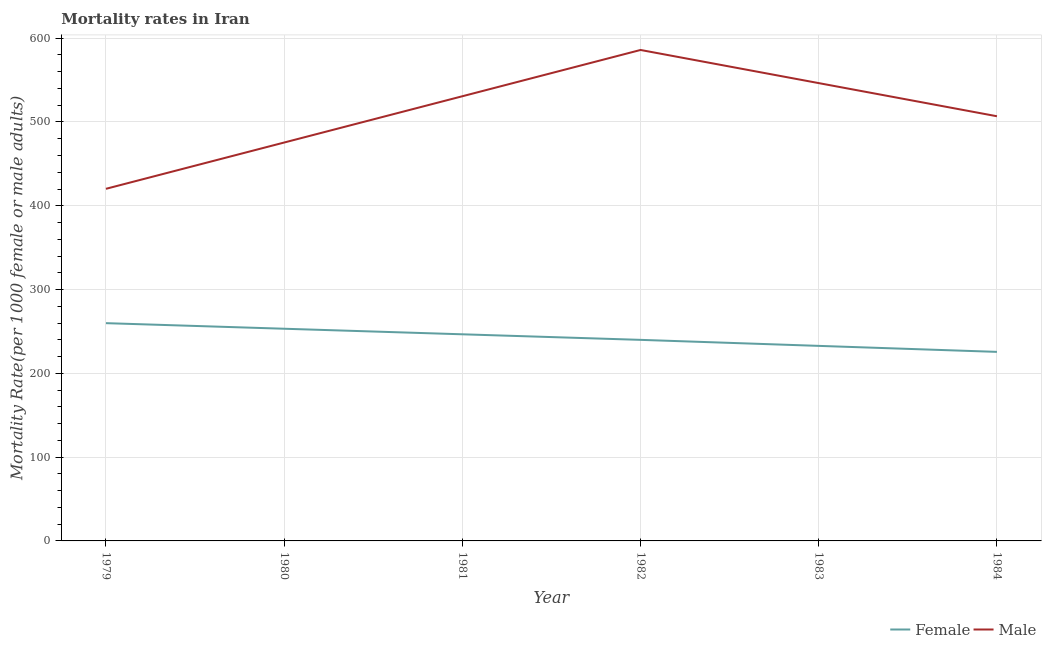How many different coloured lines are there?
Your response must be concise. 2. What is the female mortality rate in 1979?
Provide a succinct answer. 259.89. Across all years, what is the maximum female mortality rate?
Your answer should be very brief. 259.89. Across all years, what is the minimum female mortality rate?
Your response must be concise. 225.63. In which year was the female mortality rate minimum?
Ensure brevity in your answer.  1984. What is the total male mortality rate in the graph?
Ensure brevity in your answer.  3065.62. What is the difference between the male mortality rate in 1979 and that in 1983?
Keep it short and to the point. -126.16. What is the difference between the male mortality rate in 1979 and the female mortality rate in 1980?
Offer a very short reply. 166.99. What is the average male mortality rate per year?
Give a very brief answer. 510.94. In the year 1979, what is the difference between the male mortality rate and female mortality rate?
Your answer should be very brief. 160.35. What is the ratio of the male mortality rate in 1981 to that in 1982?
Your answer should be compact. 0.91. Is the male mortality rate in 1980 less than that in 1981?
Provide a short and direct response. Yes. Is the difference between the female mortality rate in 1981 and 1982 greater than the difference between the male mortality rate in 1981 and 1982?
Provide a succinct answer. Yes. What is the difference between the highest and the second highest female mortality rate?
Provide a short and direct response. 6.64. What is the difference between the highest and the lowest male mortality rate?
Ensure brevity in your answer.  165.71. Is the female mortality rate strictly less than the male mortality rate over the years?
Provide a succinct answer. Yes. How many lines are there?
Your answer should be compact. 2. What is the difference between two consecutive major ticks on the Y-axis?
Provide a succinct answer. 100. Are the values on the major ticks of Y-axis written in scientific E-notation?
Your answer should be compact. No. Does the graph contain grids?
Ensure brevity in your answer.  Yes. How many legend labels are there?
Offer a very short reply. 2. What is the title of the graph?
Ensure brevity in your answer.  Mortality rates in Iran. What is the label or title of the Y-axis?
Keep it short and to the point. Mortality Rate(per 1000 female or male adults). What is the Mortality Rate(per 1000 female or male adults) in Female in 1979?
Offer a terse response. 259.89. What is the Mortality Rate(per 1000 female or male adults) of Male in 1979?
Offer a very short reply. 420.24. What is the Mortality Rate(per 1000 female or male adults) of Female in 1980?
Keep it short and to the point. 253.25. What is the Mortality Rate(per 1000 female or male adults) in Male in 1980?
Ensure brevity in your answer.  475.48. What is the Mortality Rate(per 1000 female or male adults) in Female in 1981?
Ensure brevity in your answer.  246.61. What is the Mortality Rate(per 1000 female or male adults) of Male in 1981?
Your answer should be very brief. 530.71. What is the Mortality Rate(per 1000 female or male adults) of Female in 1982?
Give a very brief answer. 239.96. What is the Mortality Rate(per 1000 female or male adults) in Male in 1982?
Provide a succinct answer. 585.95. What is the Mortality Rate(per 1000 female or male adults) of Female in 1983?
Your answer should be very brief. 232.79. What is the Mortality Rate(per 1000 female or male adults) in Male in 1983?
Give a very brief answer. 546.4. What is the Mortality Rate(per 1000 female or male adults) of Female in 1984?
Provide a succinct answer. 225.63. What is the Mortality Rate(per 1000 female or male adults) of Male in 1984?
Make the answer very short. 506.84. Across all years, what is the maximum Mortality Rate(per 1000 female or male adults) of Female?
Your answer should be very brief. 259.89. Across all years, what is the maximum Mortality Rate(per 1000 female or male adults) of Male?
Ensure brevity in your answer.  585.95. Across all years, what is the minimum Mortality Rate(per 1000 female or male adults) in Female?
Provide a succinct answer. 225.63. Across all years, what is the minimum Mortality Rate(per 1000 female or male adults) in Male?
Your answer should be compact. 420.24. What is the total Mortality Rate(per 1000 female or male adults) in Female in the graph?
Offer a terse response. 1458.13. What is the total Mortality Rate(per 1000 female or male adults) of Male in the graph?
Keep it short and to the point. 3065.62. What is the difference between the Mortality Rate(per 1000 female or male adults) of Female in 1979 and that in 1980?
Offer a very short reply. 6.64. What is the difference between the Mortality Rate(per 1000 female or male adults) of Male in 1979 and that in 1980?
Ensure brevity in your answer.  -55.24. What is the difference between the Mortality Rate(per 1000 female or male adults) of Female in 1979 and that in 1981?
Offer a terse response. 13.29. What is the difference between the Mortality Rate(per 1000 female or male adults) of Male in 1979 and that in 1981?
Offer a very short reply. -110.47. What is the difference between the Mortality Rate(per 1000 female or male adults) of Female in 1979 and that in 1982?
Your answer should be compact. 19.93. What is the difference between the Mortality Rate(per 1000 female or male adults) of Male in 1979 and that in 1982?
Provide a short and direct response. -165.71. What is the difference between the Mortality Rate(per 1000 female or male adults) in Female in 1979 and that in 1983?
Ensure brevity in your answer.  27.1. What is the difference between the Mortality Rate(per 1000 female or male adults) in Male in 1979 and that in 1983?
Provide a succinct answer. -126.16. What is the difference between the Mortality Rate(per 1000 female or male adults) of Female in 1979 and that in 1984?
Ensure brevity in your answer.  34.27. What is the difference between the Mortality Rate(per 1000 female or male adults) in Male in 1979 and that in 1984?
Keep it short and to the point. -86.6. What is the difference between the Mortality Rate(per 1000 female or male adults) in Female in 1980 and that in 1981?
Make the answer very short. 6.64. What is the difference between the Mortality Rate(per 1000 female or male adults) in Male in 1980 and that in 1981?
Give a very brief answer. -55.24. What is the difference between the Mortality Rate(per 1000 female or male adults) of Female in 1980 and that in 1982?
Provide a short and direct response. 13.29. What is the difference between the Mortality Rate(per 1000 female or male adults) of Male in 1980 and that in 1982?
Your answer should be very brief. -110.47. What is the difference between the Mortality Rate(per 1000 female or male adults) of Female in 1980 and that in 1983?
Provide a succinct answer. 20.46. What is the difference between the Mortality Rate(per 1000 female or male adults) of Male in 1980 and that in 1983?
Keep it short and to the point. -70.92. What is the difference between the Mortality Rate(per 1000 female or male adults) in Female in 1980 and that in 1984?
Keep it short and to the point. 27.62. What is the difference between the Mortality Rate(per 1000 female or male adults) in Male in 1980 and that in 1984?
Keep it short and to the point. -31.36. What is the difference between the Mortality Rate(per 1000 female or male adults) of Female in 1981 and that in 1982?
Your answer should be compact. 6.64. What is the difference between the Mortality Rate(per 1000 female or male adults) in Male in 1981 and that in 1982?
Provide a succinct answer. -55.24. What is the difference between the Mortality Rate(per 1000 female or male adults) of Female in 1981 and that in 1983?
Your answer should be compact. 13.81. What is the difference between the Mortality Rate(per 1000 female or male adults) of Male in 1981 and that in 1983?
Provide a succinct answer. -15.68. What is the difference between the Mortality Rate(per 1000 female or male adults) of Female in 1981 and that in 1984?
Ensure brevity in your answer.  20.98. What is the difference between the Mortality Rate(per 1000 female or male adults) of Male in 1981 and that in 1984?
Offer a very short reply. 23.87. What is the difference between the Mortality Rate(per 1000 female or male adults) in Female in 1982 and that in 1983?
Your answer should be very brief. 7.17. What is the difference between the Mortality Rate(per 1000 female or male adults) in Male in 1982 and that in 1983?
Keep it short and to the point. 39.55. What is the difference between the Mortality Rate(per 1000 female or male adults) in Female in 1982 and that in 1984?
Make the answer very short. 14.33. What is the difference between the Mortality Rate(per 1000 female or male adults) in Male in 1982 and that in 1984?
Make the answer very short. 79.11. What is the difference between the Mortality Rate(per 1000 female or male adults) in Female in 1983 and that in 1984?
Ensure brevity in your answer.  7.17. What is the difference between the Mortality Rate(per 1000 female or male adults) in Male in 1983 and that in 1984?
Your answer should be very brief. 39.55. What is the difference between the Mortality Rate(per 1000 female or male adults) in Female in 1979 and the Mortality Rate(per 1000 female or male adults) in Male in 1980?
Give a very brief answer. -215.58. What is the difference between the Mortality Rate(per 1000 female or male adults) of Female in 1979 and the Mortality Rate(per 1000 female or male adults) of Male in 1981?
Your response must be concise. -270.82. What is the difference between the Mortality Rate(per 1000 female or male adults) in Female in 1979 and the Mortality Rate(per 1000 female or male adults) in Male in 1982?
Provide a succinct answer. -326.06. What is the difference between the Mortality Rate(per 1000 female or male adults) of Female in 1979 and the Mortality Rate(per 1000 female or male adults) of Male in 1983?
Offer a terse response. -286.5. What is the difference between the Mortality Rate(per 1000 female or male adults) in Female in 1979 and the Mortality Rate(per 1000 female or male adults) in Male in 1984?
Provide a short and direct response. -246.95. What is the difference between the Mortality Rate(per 1000 female or male adults) of Female in 1980 and the Mortality Rate(per 1000 female or male adults) of Male in 1981?
Keep it short and to the point. -277.46. What is the difference between the Mortality Rate(per 1000 female or male adults) in Female in 1980 and the Mortality Rate(per 1000 female or male adults) in Male in 1982?
Offer a very short reply. -332.7. What is the difference between the Mortality Rate(per 1000 female or male adults) of Female in 1980 and the Mortality Rate(per 1000 female or male adults) of Male in 1983?
Provide a succinct answer. -293.15. What is the difference between the Mortality Rate(per 1000 female or male adults) in Female in 1980 and the Mortality Rate(per 1000 female or male adults) in Male in 1984?
Ensure brevity in your answer.  -253.59. What is the difference between the Mortality Rate(per 1000 female or male adults) in Female in 1981 and the Mortality Rate(per 1000 female or male adults) in Male in 1982?
Make the answer very short. -339.35. What is the difference between the Mortality Rate(per 1000 female or male adults) in Female in 1981 and the Mortality Rate(per 1000 female or male adults) in Male in 1983?
Your answer should be very brief. -299.79. What is the difference between the Mortality Rate(per 1000 female or male adults) in Female in 1981 and the Mortality Rate(per 1000 female or male adults) in Male in 1984?
Your response must be concise. -260.24. What is the difference between the Mortality Rate(per 1000 female or male adults) of Female in 1982 and the Mortality Rate(per 1000 female or male adults) of Male in 1983?
Give a very brief answer. -306.44. What is the difference between the Mortality Rate(per 1000 female or male adults) of Female in 1982 and the Mortality Rate(per 1000 female or male adults) of Male in 1984?
Keep it short and to the point. -266.88. What is the difference between the Mortality Rate(per 1000 female or male adults) in Female in 1983 and the Mortality Rate(per 1000 female or male adults) in Male in 1984?
Keep it short and to the point. -274.05. What is the average Mortality Rate(per 1000 female or male adults) in Female per year?
Provide a short and direct response. 243.02. What is the average Mortality Rate(per 1000 female or male adults) in Male per year?
Your response must be concise. 510.94. In the year 1979, what is the difference between the Mortality Rate(per 1000 female or male adults) of Female and Mortality Rate(per 1000 female or male adults) of Male?
Provide a succinct answer. -160.35. In the year 1980, what is the difference between the Mortality Rate(per 1000 female or male adults) of Female and Mortality Rate(per 1000 female or male adults) of Male?
Provide a succinct answer. -222.23. In the year 1981, what is the difference between the Mortality Rate(per 1000 female or male adults) in Female and Mortality Rate(per 1000 female or male adults) in Male?
Keep it short and to the point. -284.11. In the year 1982, what is the difference between the Mortality Rate(per 1000 female or male adults) of Female and Mortality Rate(per 1000 female or male adults) of Male?
Your answer should be very brief. -345.99. In the year 1983, what is the difference between the Mortality Rate(per 1000 female or male adults) of Female and Mortality Rate(per 1000 female or male adults) of Male?
Your answer should be compact. -313.6. In the year 1984, what is the difference between the Mortality Rate(per 1000 female or male adults) of Female and Mortality Rate(per 1000 female or male adults) of Male?
Your answer should be very brief. -281.22. What is the ratio of the Mortality Rate(per 1000 female or male adults) of Female in 1979 to that in 1980?
Make the answer very short. 1.03. What is the ratio of the Mortality Rate(per 1000 female or male adults) in Male in 1979 to that in 1980?
Give a very brief answer. 0.88. What is the ratio of the Mortality Rate(per 1000 female or male adults) in Female in 1979 to that in 1981?
Make the answer very short. 1.05. What is the ratio of the Mortality Rate(per 1000 female or male adults) in Male in 1979 to that in 1981?
Ensure brevity in your answer.  0.79. What is the ratio of the Mortality Rate(per 1000 female or male adults) in Female in 1979 to that in 1982?
Offer a very short reply. 1.08. What is the ratio of the Mortality Rate(per 1000 female or male adults) of Male in 1979 to that in 1982?
Offer a very short reply. 0.72. What is the ratio of the Mortality Rate(per 1000 female or male adults) of Female in 1979 to that in 1983?
Provide a short and direct response. 1.12. What is the ratio of the Mortality Rate(per 1000 female or male adults) in Male in 1979 to that in 1983?
Your response must be concise. 0.77. What is the ratio of the Mortality Rate(per 1000 female or male adults) of Female in 1979 to that in 1984?
Provide a succinct answer. 1.15. What is the ratio of the Mortality Rate(per 1000 female or male adults) of Male in 1979 to that in 1984?
Your answer should be compact. 0.83. What is the ratio of the Mortality Rate(per 1000 female or male adults) in Female in 1980 to that in 1981?
Provide a short and direct response. 1.03. What is the ratio of the Mortality Rate(per 1000 female or male adults) in Male in 1980 to that in 1981?
Your answer should be compact. 0.9. What is the ratio of the Mortality Rate(per 1000 female or male adults) of Female in 1980 to that in 1982?
Offer a very short reply. 1.06. What is the ratio of the Mortality Rate(per 1000 female or male adults) in Male in 1980 to that in 1982?
Keep it short and to the point. 0.81. What is the ratio of the Mortality Rate(per 1000 female or male adults) in Female in 1980 to that in 1983?
Provide a succinct answer. 1.09. What is the ratio of the Mortality Rate(per 1000 female or male adults) in Male in 1980 to that in 1983?
Your answer should be very brief. 0.87. What is the ratio of the Mortality Rate(per 1000 female or male adults) of Female in 1980 to that in 1984?
Your answer should be very brief. 1.12. What is the ratio of the Mortality Rate(per 1000 female or male adults) in Male in 1980 to that in 1984?
Ensure brevity in your answer.  0.94. What is the ratio of the Mortality Rate(per 1000 female or male adults) of Female in 1981 to that in 1982?
Your answer should be compact. 1.03. What is the ratio of the Mortality Rate(per 1000 female or male adults) of Male in 1981 to that in 1982?
Ensure brevity in your answer.  0.91. What is the ratio of the Mortality Rate(per 1000 female or male adults) of Female in 1981 to that in 1983?
Offer a very short reply. 1.06. What is the ratio of the Mortality Rate(per 1000 female or male adults) of Male in 1981 to that in 1983?
Your answer should be very brief. 0.97. What is the ratio of the Mortality Rate(per 1000 female or male adults) in Female in 1981 to that in 1984?
Your answer should be compact. 1.09. What is the ratio of the Mortality Rate(per 1000 female or male adults) in Male in 1981 to that in 1984?
Your answer should be compact. 1.05. What is the ratio of the Mortality Rate(per 1000 female or male adults) of Female in 1982 to that in 1983?
Provide a succinct answer. 1.03. What is the ratio of the Mortality Rate(per 1000 female or male adults) of Male in 1982 to that in 1983?
Provide a short and direct response. 1.07. What is the ratio of the Mortality Rate(per 1000 female or male adults) of Female in 1982 to that in 1984?
Provide a succinct answer. 1.06. What is the ratio of the Mortality Rate(per 1000 female or male adults) in Male in 1982 to that in 1984?
Provide a short and direct response. 1.16. What is the ratio of the Mortality Rate(per 1000 female or male adults) in Female in 1983 to that in 1984?
Provide a short and direct response. 1.03. What is the ratio of the Mortality Rate(per 1000 female or male adults) of Male in 1983 to that in 1984?
Your answer should be very brief. 1.08. What is the difference between the highest and the second highest Mortality Rate(per 1000 female or male adults) in Female?
Your answer should be compact. 6.64. What is the difference between the highest and the second highest Mortality Rate(per 1000 female or male adults) of Male?
Provide a short and direct response. 39.55. What is the difference between the highest and the lowest Mortality Rate(per 1000 female or male adults) of Female?
Keep it short and to the point. 34.27. What is the difference between the highest and the lowest Mortality Rate(per 1000 female or male adults) in Male?
Keep it short and to the point. 165.71. 